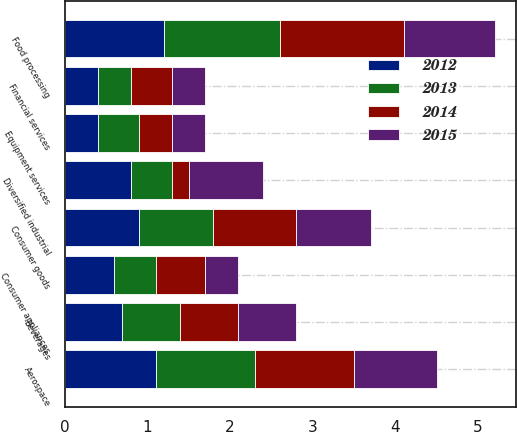Convert chart. <chart><loc_0><loc_0><loc_500><loc_500><stacked_bar_chart><ecel><fcel>Aerospace<fcel>Beverages<fcel>Consumer appliances<fcel>Consumer goods<fcel>Diversified industrial<fcel>Equipment services<fcel>Financial services<fcel>Food processing<nl><fcel>2015<fcel>1<fcel>0.7<fcel>0.4<fcel>0.9<fcel>0.9<fcel>0.4<fcel>0.4<fcel>1.1<nl><fcel>2012<fcel>1.1<fcel>0.7<fcel>0.6<fcel>0.9<fcel>0.8<fcel>0.4<fcel>0.4<fcel>1.2<nl><fcel>2013<fcel>1.2<fcel>0.7<fcel>0.5<fcel>0.9<fcel>0.5<fcel>0.5<fcel>0.4<fcel>1.4<nl><fcel>2014<fcel>1.2<fcel>0.7<fcel>0.6<fcel>1<fcel>0.2<fcel>0.4<fcel>0.5<fcel>1.5<nl></chart> 